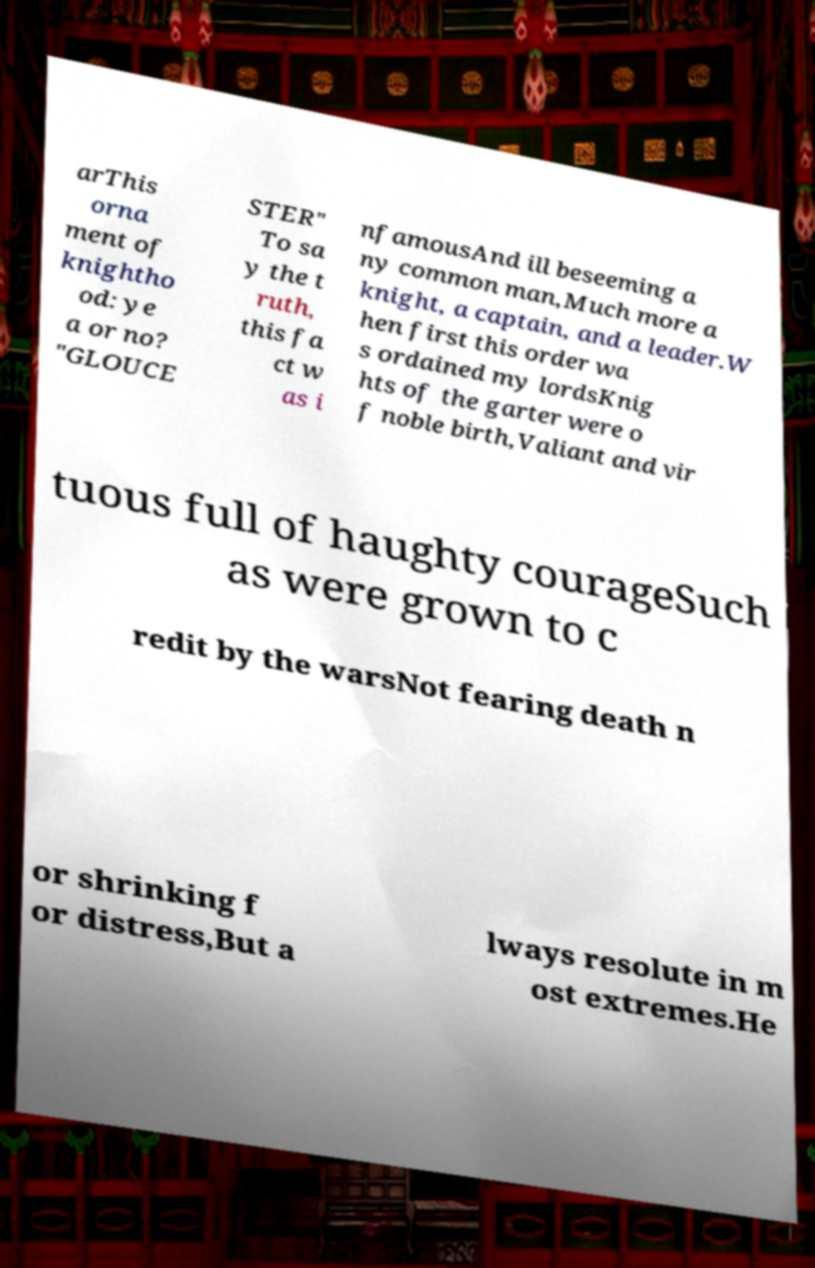I need the written content from this picture converted into text. Can you do that? arThis orna ment of knightho od: ye a or no? "GLOUCE STER" To sa y the t ruth, this fa ct w as i nfamousAnd ill beseeming a ny common man,Much more a knight, a captain, and a leader.W hen first this order wa s ordained my lordsKnig hts of the garter were o f noble birth,Valiant and vir tuous full of haughty courageSuch as were grown to c redit by the warsNot fearing death n or shrinking f or distress,But a lways resolute in m ost extremes.He 